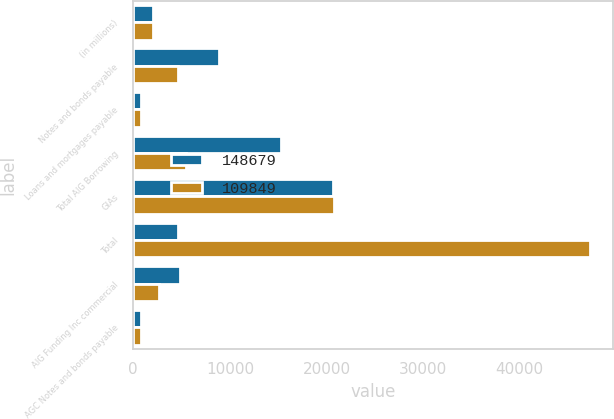Convert chart. <chart><loc_0><loc_0><loc_500><loc_500><stacked_bar_chart><ecel><fcel>(in millions)<fcel>Notes and bonds payable<fcel>Loans and mortgages payable<fcel>Total AIG Borrowing<fcel>GIAs<fcel>Total<fcel>AIG Funding Inc commercial<fcel>AGC Notes and bonds payable<nl><fcel>148679<fcel>2006<fcel>8915<fcel>841<fcel>15296<fcel>20664<fcel>4607<fcel>4821<fcel>797<nl><fcel>109849<fcel>2005<fcel>4607<fcel>814<fcel>5421<fcel>20811<fcel>47274<fcel>2694<fcel>797<nl></chart> 